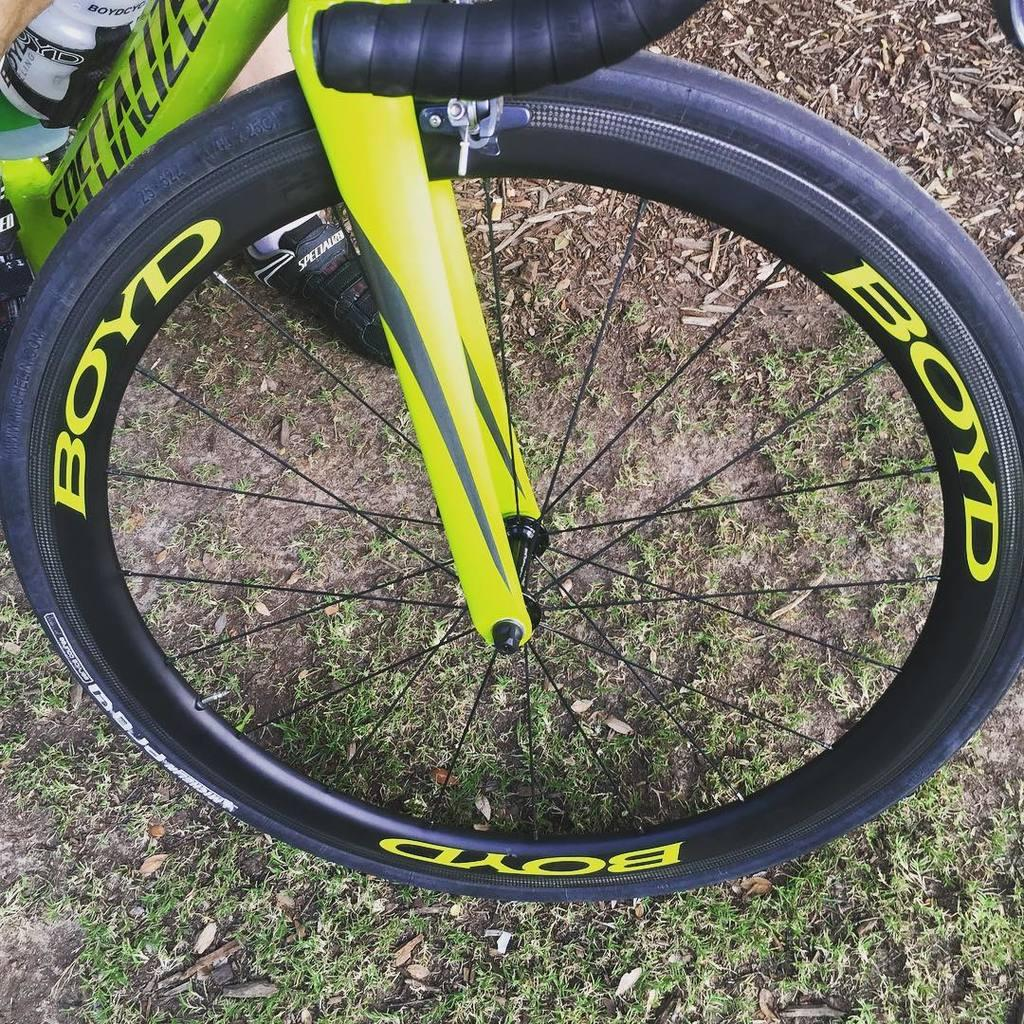What is the main object in the image? There is a bicycle in the image. Which part of the bicycle is visible in the image? The image shows the front part of the bicycle. Can you see any part of a person in the image? Yes, there is a leg of a person in the image. What can be seen in the background of the image? There is grass in the background of the image. How does the faucet affect the slope of the bicycle in the image? There is no faucet present in the image, and therefore no effect on the slope of the bicycle. 